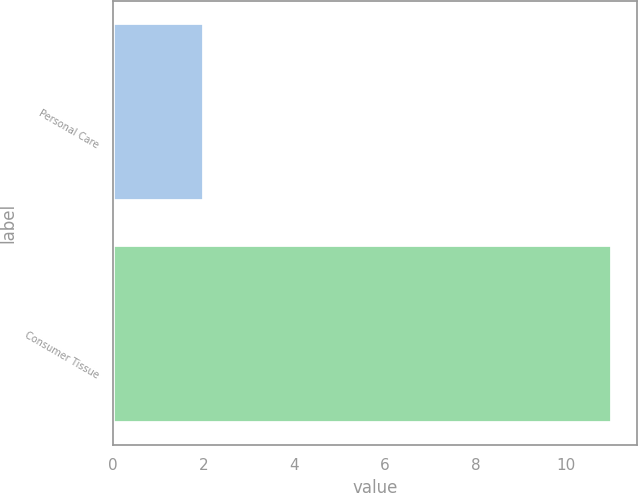Convert chart. <chart><loc_0><loc_0><loc_500><loc_500><bar_chart><fcel>Personal Care<fcel>Consumer Tissue<nl><fcel>2<fcel>11<nl></chart> 